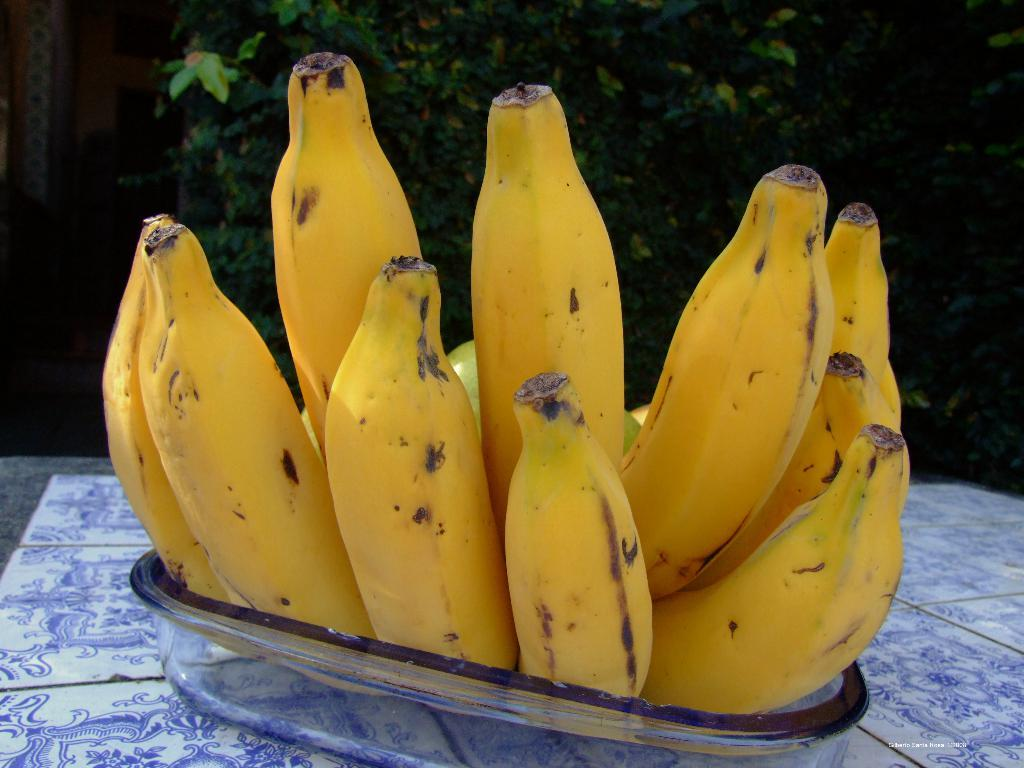What type of fruit is in the glass bowl in the image? There is a cluster of bananas in a glass bowl in the image. What is the glass bowl resting on? The glass bowl is on tiles. What can be seen in the background of the image? There are trees in the background of the image. Is there any additional information or marking on the image? Yes, there is a watermark on the image. What type of beast is present in the image? There is no beast present in the image; it features a cluster of bananas in a glass bowl on tiles, with trees in the background and a watermark. 